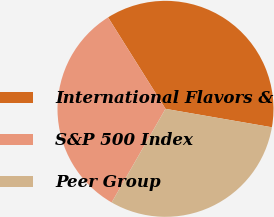Convert chart to OTSL. <chart><loc_0><loc_0><loc_500><loc_500><pie_chart><fcel>International Flavors &<fcel>S&P 500 Index<fcel>Peer Group<nl><fcel>36.65%<fcel>32.77%<fcel>30.57%<nl></chart> 